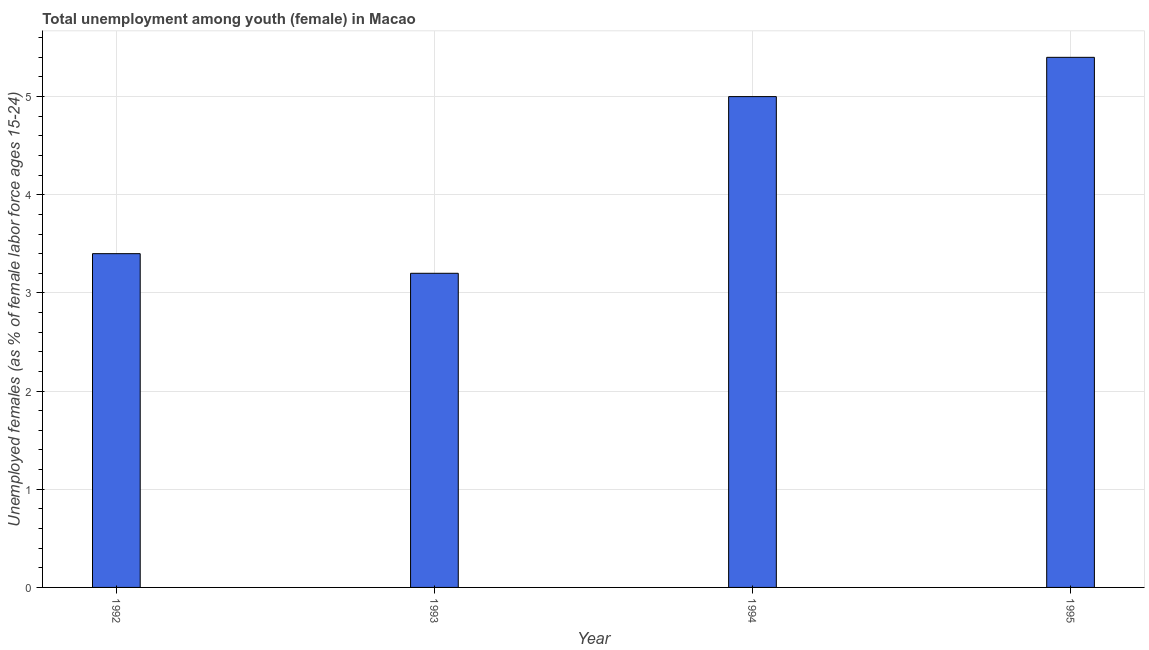Does the graph contain grids?
Give a very brief answer. Yes. What is the title of the graph?
Provide a short and direct response. Total unemployment among youth (female) in Macao. What is the label or title of the X-axis?
Your response must be concise. Year. What is the label or title of the Y-axis?
Offer a terse response. Unemployed females (as % of female labor force ages 15-24). What is the unemployed female youth population in 1994?
Your answer should be very brief. 5. Across all years, what is the maximum unemployed female youth population?
Make the answer very short. 5.4. Across all years, what is the minimum unemployed female youth population?
Your response must be concise. 3.2. In which year was the unemployed female youth population maximum?
Provide a short and direct response. 1995. In which year was the unemployed female youth population minimum?
Ensure brevity in your answer.  1993. What is the sum of the unemployed female youth population?
Ensure brevity in your answer.  17. What is the difference between the unemployed female youth population in 1993 and 1994?
Your answer should be compact. -1.8. What is the average unemployed female youth population per year?
Make the answer very short. 4.25. What is the median unemployed female youth population?
Offer a very short reply. 4.2. In how many years, is the unemployed female youth population greater than 1.2 %?
Your answer should be compact. 4. Do a majority of the years between 1993 and 1992 (inclusive) have unemployed female youth population greater than 0.6 %?
Your answer should be very brief. No. What is the ratio of the unemployed female youth population in 1992 to that in 1994?
Provide a succinct answer. 0.68. Is the unemployed female youth population in 1994 less than that in 1995?
Keep it short and to the point. Yes. What is the difference between the highest and the second highest unemployed female youth population?
Your answer should be compact. 0.4. Is the sum of the unemployed female youth population in 1994 and 1995 greater than the maximum unemployed female youth population across all years?
Give a very brief answer. Yes. In how many years, is the unemployed female youth population greater than the average unemployed female youth population taken over all years?
Give a very brief answer. 2. Are all the bars in the graph horizontal?
Your answer should be very brief. No. How many years are there in the graph?
Make the answer very short. 4. What is the Unemployed females (as % of female labor force ages 15-24) in 1992?
Offer a terse response. 3.4. What is the Unemployed females (as % of female labor force ages 15-24) in 1993?
Ensure brevity in your answer.  3.2. What is the Unemployed females (as % of female labor force ages 15-24) in 1995?
Keep it short and to the point. 5.4. What is the difference between the Unemployed females (as % of female labor force ages 15-24) in 1992 and 1993?
Your answer should be compact. 0.2. What is the difference between the Unemployed females (as % of female labor force ages 15-24) in 1992 and 1995?
Your answer should be compact. -2. What is the difference between the Unemployed females (as % of female labor force ages 15-24) in 1993 and 1995?
Ensure brevity in your answer.  -2.2. What is the ratio of the Unemployed females (as % of female labor force ages 15-24) in 1992 to that in 1993?
Provide a succinct answer. 1.06. What is the ratio of the Unemployed females (as % of female labor force ages 15-24) in 1992 to that in 1994?
Offer a terse response. 0.68. What is the ratio of the Unemployed females (as % of female labor force ages 15-24) in 1992 to that in 1995?
Provide a succinct answer. 0.63. What is the ratio of the Unemployed females (as % of female labor force ages 15-24) in 1993 to that in 1994?
Your answer should be very brief. 0.64. What is the ratio of the Unemployed females (as % of female labor force ages 15-24) in 1993 to that in 1995?
Offer a very short reply. 0.59. What is the ratio of the Unemployed females (as % of female labor force ages 15-24) in 1994 to that in 1995?
Offer a very short reply. 0.93. 